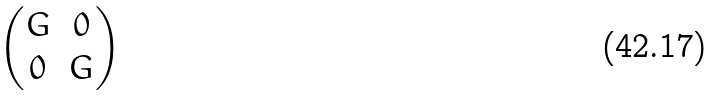Convert formula to latex. <formula><loc_0><loc_0><loc_500><loc_500>\begin{pmatrix} G & 0 \\ 0 & G \end{pmatrix}</formula> 